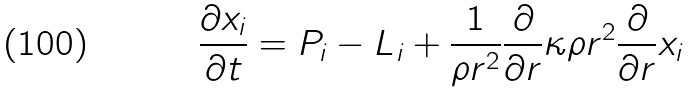<formula> <loc_0><loc_0><loc_500><loc_500>\frac { \partial x _ { i } } { \partial t } = P _ { i } - L _ { i } + \frac { 1 } { \rho r ^ { 2 } } \frac { \partial } { \partial r } \kappa \rho r ^ { 2 } \frac { \partial } { \partial r } x _ { i }</formula> 